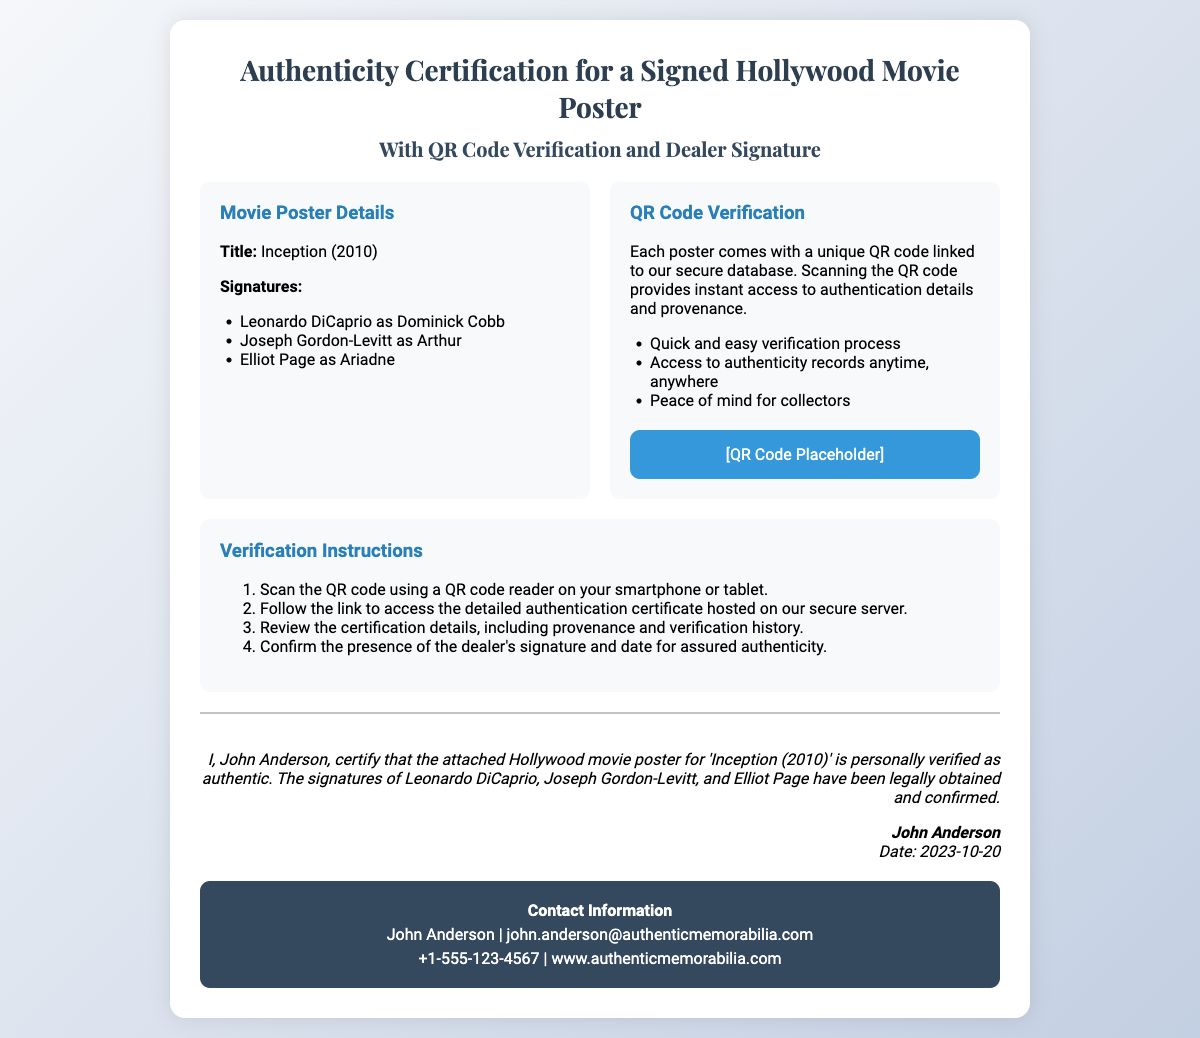What is the title of the movie? The title of the movie is explicitly mentioned in the document under "Movie Poster Details."
Answer: Inception (2010) Who are the signed actors? The document lists the actors' names under "Signatures."
Answer: Leonardo DiCaprio, Joseph Gordon-Levitt, Elliot Page What does the QR code verify? The document states that the QR code links to a database that provides authentication details and provenance.
Answer: Authentication details and provenance Who certifies the authenticity of the poster? The dealer who provides the certification is named at the end of the document.
Answer: John Anderson What is the verification date? The verification date is indicated in the dealer's certification statement.
Answer: 2023-10-20 What is the contact email for the dealer? The contact email is provided in the "Contact Information" section of the document.
Answer: john.anderson@authenticmemorabilia.com How many steps are included in the verification instructions? The document outlines a numbered list of verification steps.
Answer: Four steps What benefits does the QR code provide? The document highlights multiple advantages of using the QR code for verification.
Answer: Peace of mind for collectors What is the dealer's phone number? The dealer's phone number is listed in the contact section of the document.
Answer: +1-555-123-4567 